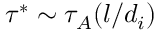Convert formula to latex. <formula><loc_0><loc_0><loc_500><loc_500>\tau ^ { * } \sim \tau _ { A } ( l / d _ { i } )</formula> 